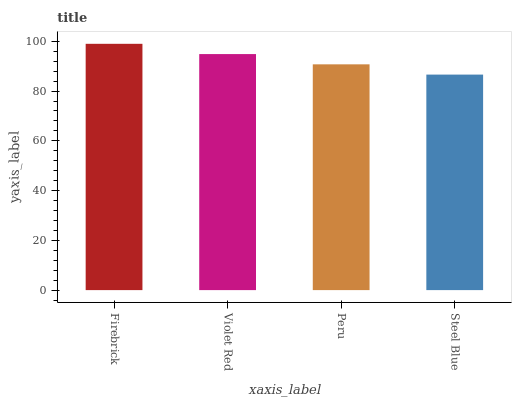Is Steel Blue the minimum?
Answer yes or no. Yes. Is Firebrick the maximum?
Answer yes or no. Yes. Is Violet Red the minimum?
Answer yes or no. No. Is Violet Red the maximum?
Answer yes or no. No. Is Firebrick greater than Violet Red?
Answer yes or no. Yes. Is Violet Red less than Firebrick?
Answer yes or no. Yes. Is Violet Red greater than Firebrick?
Answer yes or no. No. Is Firebrick less than Violet Red?
Answer yes or no. No. Is Violet Red the high median?
Answer yes or no. Yes. Is Peru the low median?
Answer yes or no. Yes. Is Steel Blue the high median?
Answer yes or no. No. Is Steel Blue the low median?
Answer yes or no. No. 